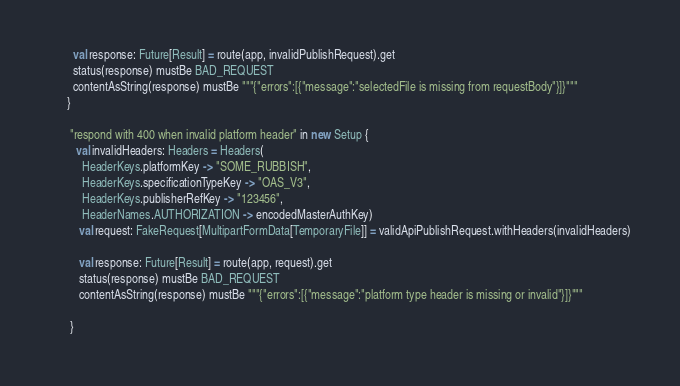Convert code to text. <code><loc_0><loc_0><loc_500><loc_500><_Scala_>

        val response: Future[Result] = route(app, invalidPublishRequest).get
        status(response) mustBe BAD_REQUEST
        contentAsString(response) mustBe """{"errors":[{"message":"selectedFile is missing from requestBody"}]}"""
      }

       "respond with 400 when invalid platform header" in new Setup {
         val invalidHeaders: Headers = Headers(
           HeaderKeys.platformKey -> "SOME_RUBBISH",
           HeaderKeys.specificationTypeKey -> "OAS_V3",
           HeaderKeys.publisherRefKey -> "123456",
           HeaderNames.AUTHORIZATION -> encodedMasterAuthKey)
          val request: FakeRequest[MultipartFormData[TemporaryFile]] = validApiPublishRequest.withHeaders(invalidHeaders)

          val response: Future[Result] = route(app, request).get
          status(response) mustBe BAD_REQUEST
          contentAsString(response) mustBe """{"errors":[{"message":"platform type header is missing or invalid"}]}"""

       }
</code> 